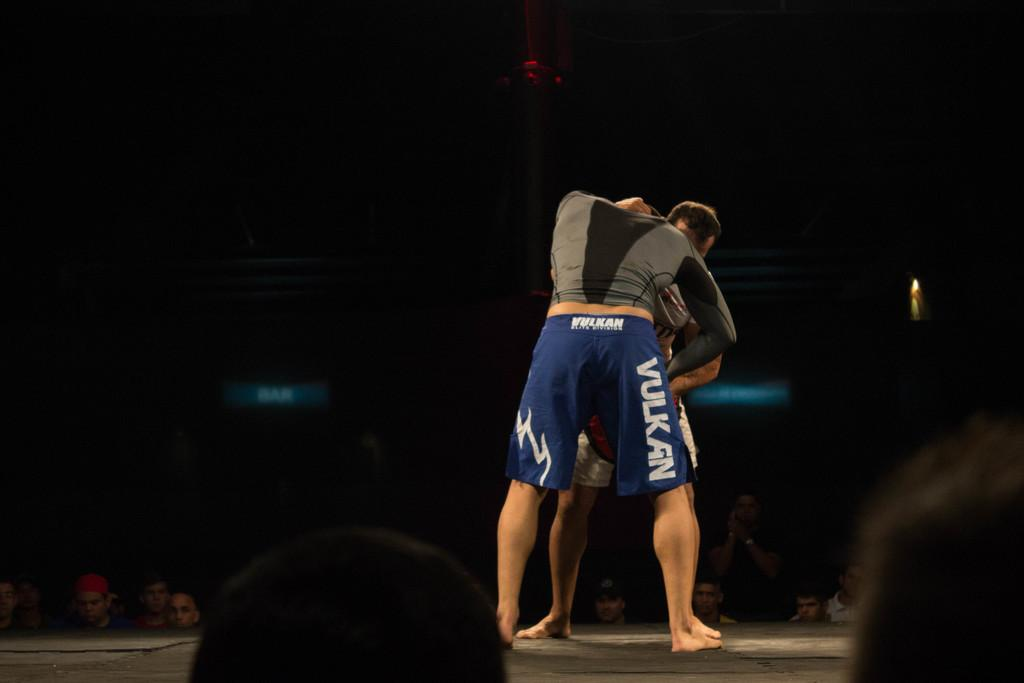<image>
Offer a succinct explanation of the picture presented. a person in a Vulkan shorts is grappling with another person 